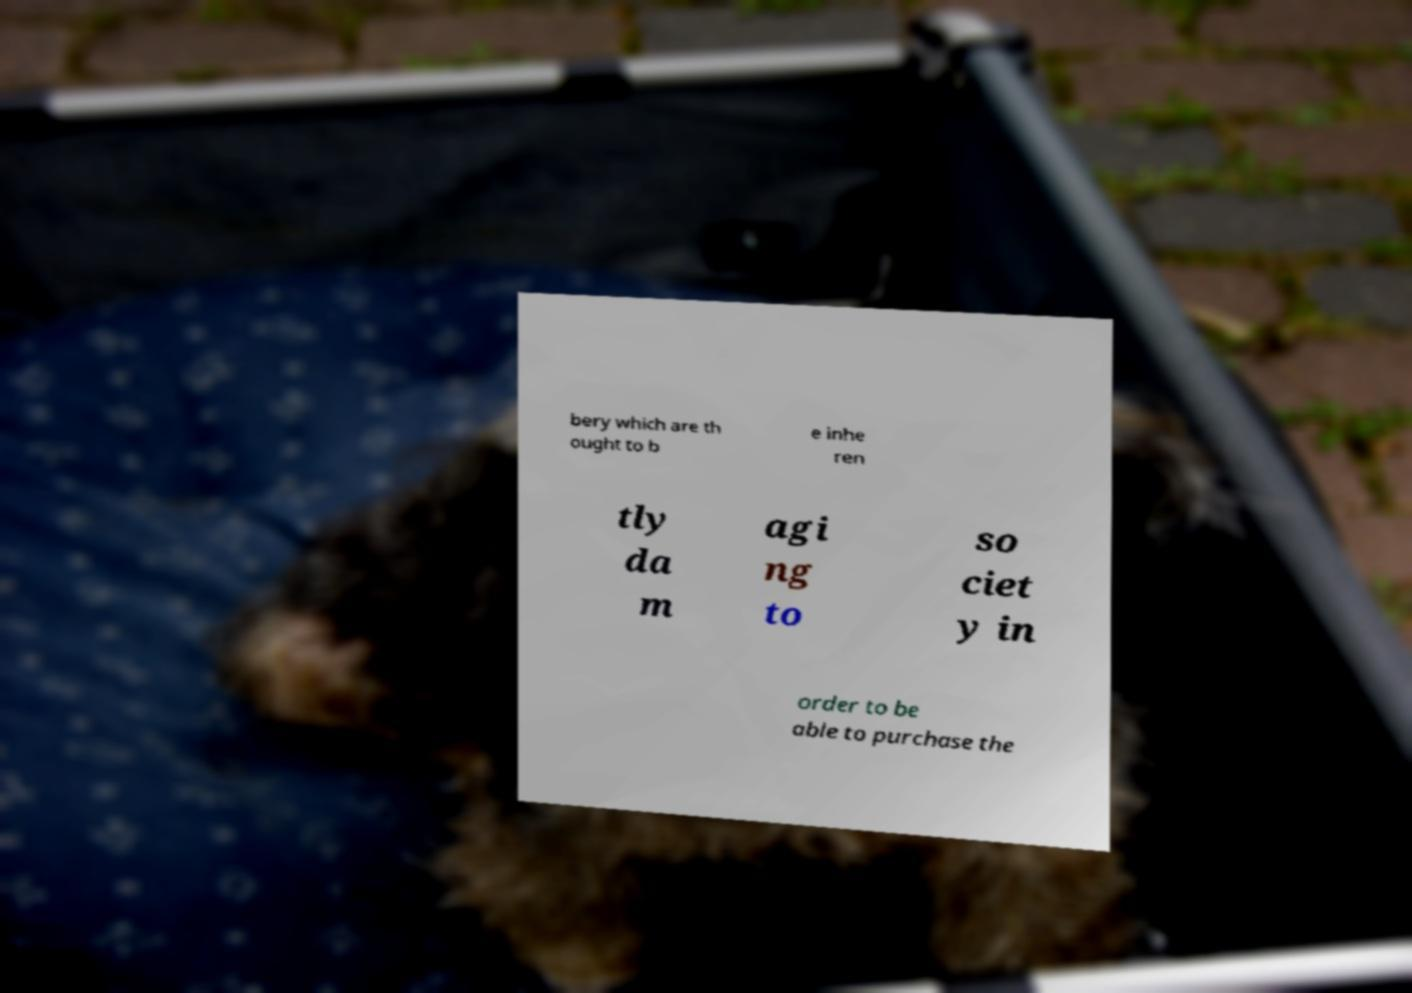Could you extract and type out the text from this image? bery which are th ought to b e inhe ren tly da m agi ng to so ciet y in order to be able to purchase the 